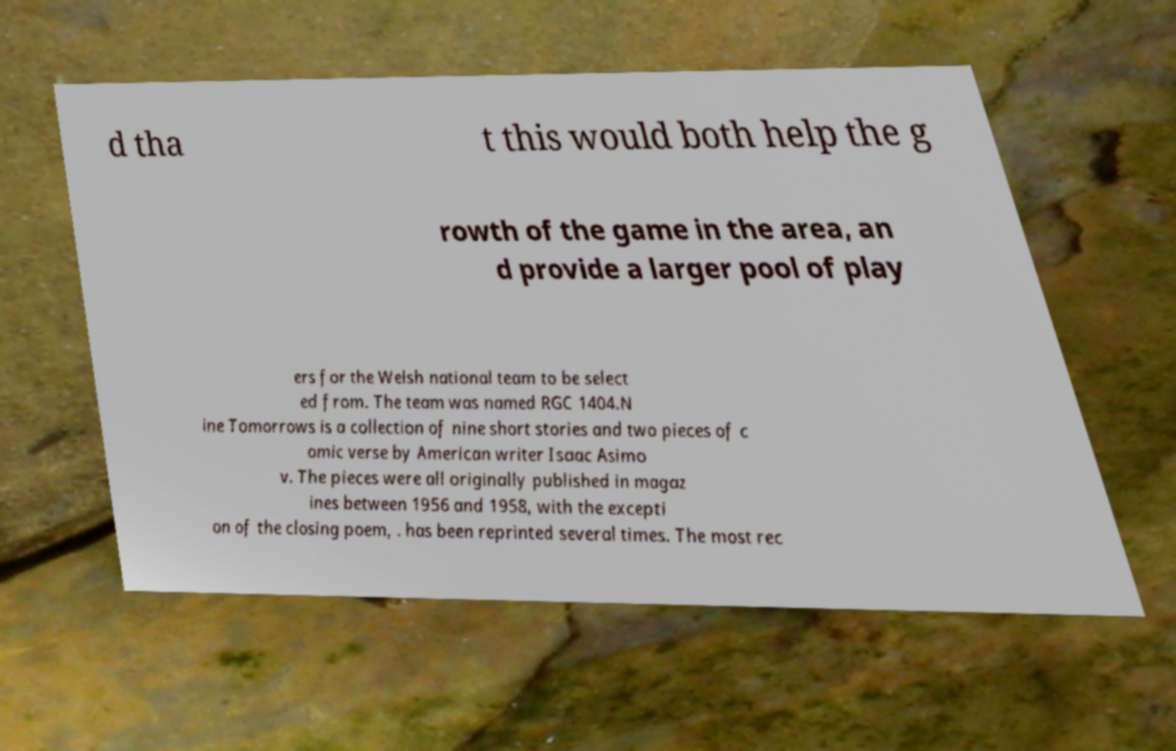Could you extract and type out the text from this image? d tha t this would both help the g rowth of the game in the area, an d provide a larger pool of play ers for the Welsh national team to be select ed from. The team was named RGC 1404.N ine Tomorrows is a collection of nine short stories and two pieces of c omic verse by American writer Isaac Asimo v. The pieces were all originally published in magaz ines between 1956 and 1958, with the excepti on of the closing poem, . has been reprinted several times. The most rec 